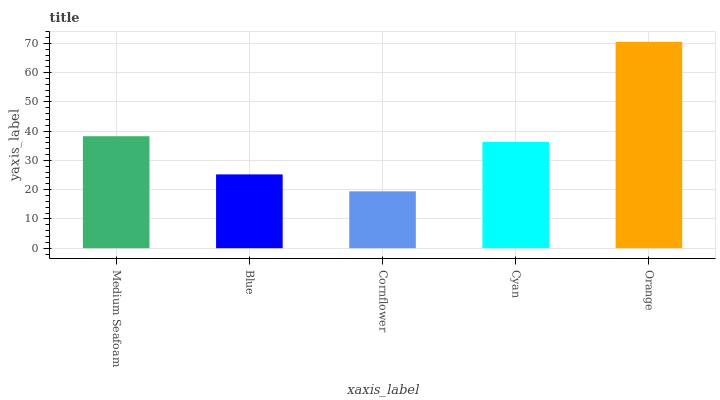Is Cornflower the minimum?
Answer yes or no. Yes. Is Orange the maximum?
Answer yes or no. Yes. Is Blue the minimum?
Answer yes or no. No. Is Blue the maximum?
Answer yes or no. No. Is Medium Seafoam greater than Blue?
Answer yes or no. Yes. Is Blue less than Medium Seafoam?
Answer yes or no. Yes. Is Blue greater than Medium Seafoam?
Answer yes or no. No. Is Medium Seafoam less than Blue?
Answer yes or no. No. Is Cyan the high median?
Answer yes or no. Yes. Is Cyan the low median?
Answer yes or no. Yes. Is Medium Seafoam the high median?
Answer yes or no. No. Is Cornflower the low median?
Answer yes or no. No. 